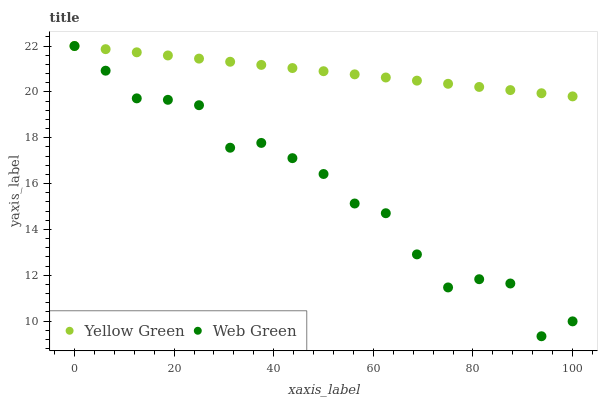Does Web Green have the minimum area under the curve?
Answer yes or no. Yes. Does Yellow Green have the maximum area under the curve?
Answer yes or no. Yes. Does Web Green have the maximum area under the curve?
Answer yes or no. No. Is Yellow Green the smoothest?
Answer yes or no. Yes. Is Web Green the roughest?
Answer yes or no. Yes. Is Web Green the smoothest?
Answer yes or no. No. Does Web Green have the lowest value?
Answer yes or no. Yes. Does Web Green have the highest value?
Answer yes or no. Yes. Does Web Green intersect Yellow Green?
Answer yes or no. Yes. Is Web Green less than Yellow Green?
Answer yes or no. No. Is Web Green greater than Yellow Green?
Answer yes or no. No. 